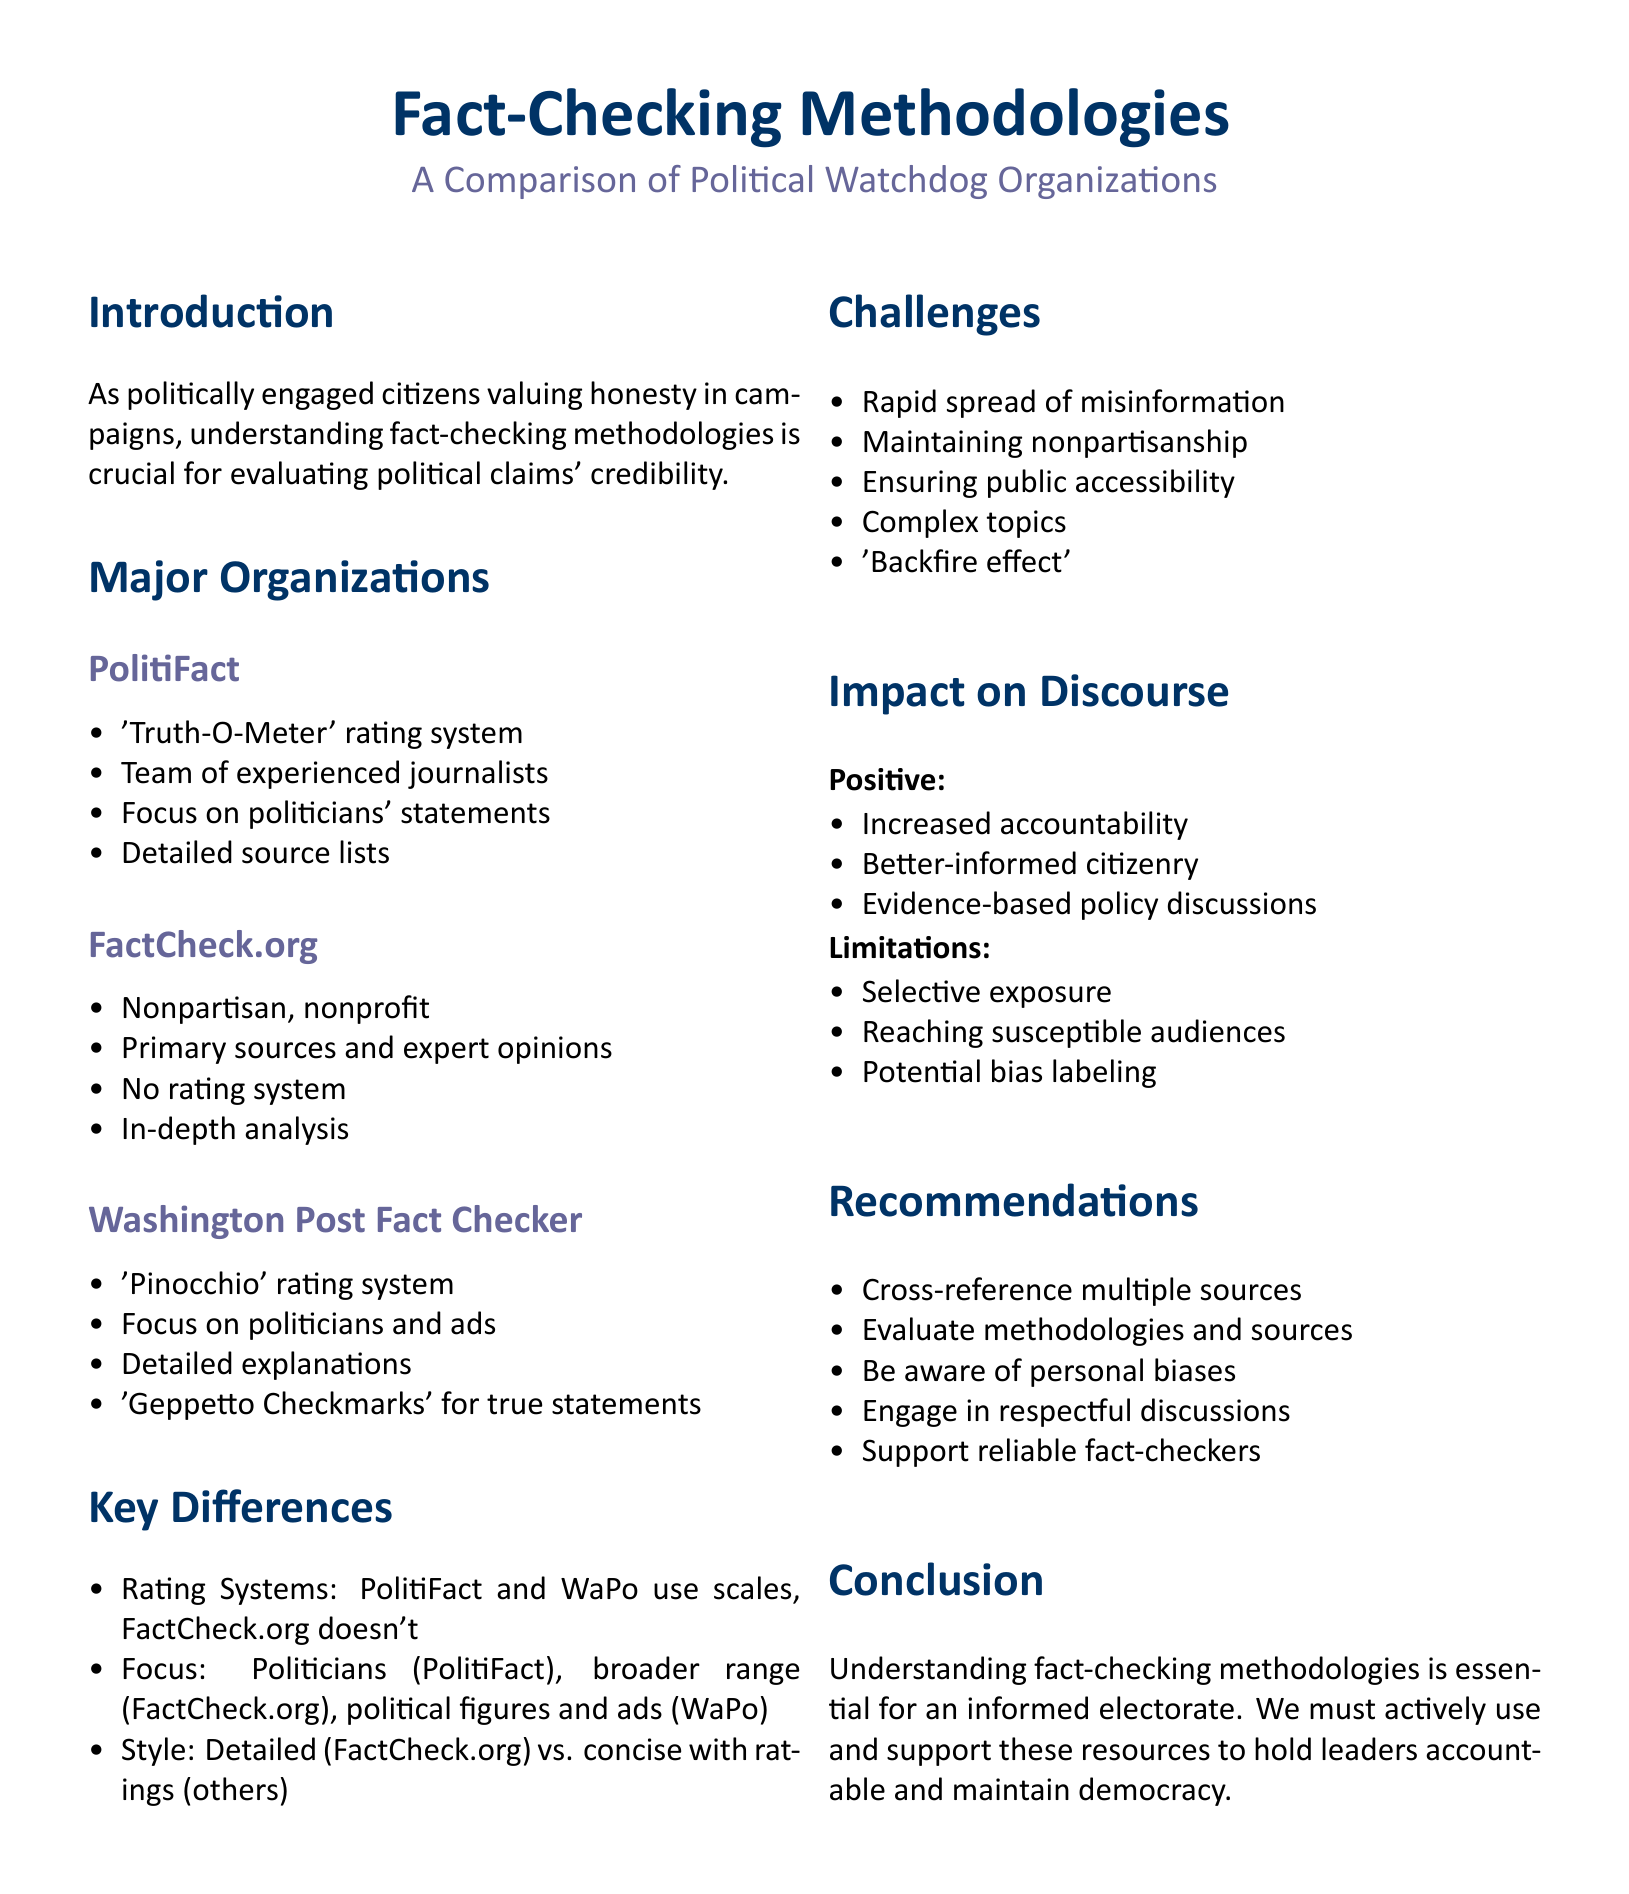What rating system does PolitiFact use? The document states that PolitiFact uses a 'Truth-O-Meter' rating system.
Answer: 'Truth-O-Meter' What type of organization is FactCheck.org? According to the document, FactCheck.org is described as a nonpartisan, nonprofit organization.
Answer: nonpartisan, nonprofit Which organization awards 'Geppetto Checkmarks'? The document specifies that the Washington Post Fact Checker occasionally awards 'Geppetto Checkmarks' for completely true statements.
Answer: Washington Post Fact Checker What is one challenge faced by fact-checking organizations? The document lists several challenges, one of which is maintaining nonpartisanship and avoiding bias.
Answer: Nonpartisanship What criteria is used to compare fact-checking organizations? The document mentions several criteria, including transparency of methodology, use of rating systems, and others.
Answer: Transparency of methodology Which organization focuses on statements by politicians and political ads? The Washington Post Fact Checker primarily focuses on statements by politicians and political ads as noted in the document.
Answer: Washington Post Fact Checker How many major fact-checking organizations are discussed? The document references three major organizations in the comparison.
Answer: three What is one recommendation for citizens regarding fact-checking? The document recommends that citizens should cross-reference multiple fact-checking sources.
Answer: Cross-reference multiple sources What positive impact do fact-checkers have on political discourse? The document notes that fact-checkers lead to increased accountability for politicians and public figures.
Answer: Increased accountability 